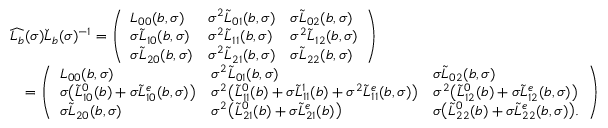Convert formula to latex. <formula><loc_0><loc_0><loc_500><loc_500>\begin{array} { r l } & { \widehat { L _ { b } } ( \sigma ) \check { L } _ { b } ( \sigma ) ^ { - 1 } = \left ( \begin{array} { l l l } { L _ { 0 0 } ( b , \sigma ) } & { \sigma ^ { 2 } \widetilde { L } _ { 0 1 } ( b , \sigma ) } & { \sigma \widetilde { L } _ { 0 2 } ( b , \sigma ) } \\ { \sigma \widetilde { L } _ { 1 0 } ( b , \sigma ) } & { \sigma ^ { 2 } \widetilde { L } _ { 1 1 } ( b , \sigma ) } & { \sigma ^ { 2 } \widetilde { L } _ { 1 2 } ( b , \sigma ) } \\ { \sigma \widetilde { L } _ { 2 0 } ( b , \sigma ) } & { \sigma ^ { 2 } \widetilde { L } _ { 2 1 } ( b , \sigma ) } & { \sigma \widetilde { L } _ { 2 2 } ( b , \sigma ) } \end{array} \right ) } \\ & { \quad = \left ( \begin{array} { l l l } { L _ { 0 0 } ( b , \sigma ) } & { \sigma ^ { 2 } \widetilde { L } _ { 0 1 } ( b , \sigma ) } & { \sigma \widetilde { L } _ { 0 2 } ( b , \sigma ) } \\ { \sigma \left ( \widetilde { L } _ { 1 0 } ^ { 0 } ( b ) + \sigma \widetilde { L } _ { 1 0 } ^ { e } ( b , \sigma ) \right ) } & { \sigma ^ { 2 } \left ( \widetilde { L } _ { 1 1 } ^ { 0 } ( b ) + \sigma \widetilde { L } _ { 1 1 } ^ { 1 } ( b ) + \sigma ^ { 2 } \widetilde { L } _ { 1 1 } ^ { e } ( b , \sigma ) \right ) } & { \sigma ^ { 2 } \left ( \widetilde { L } _ { 1 2 } ^ { 0 } ( b ) + \sigma \widetilde { L } _ { 1 2 } ^ { e } ( b , \sigma ) \right ) } \\ { \sigma \widetilde { L } _ { 2 0 } ( b , \sigma ) } & { \sigma ^ { 2 } \left ( \widetilde { L } _ { 2 1 } ^ { 0 } ( b ) + \sigma \widetilde { L } _ { 2 1 } ^ { e } ( b ) \right ) } & { \sigma \left ( \widetilde { L } _ { 2 2 } ^ { 0 } ( b ) + \sigma \widetilde { L } _ { 2 2 } ^ { e } ( b , \sigma ) \right ) . } \end{array} \right ) } \end{array}</formula> 